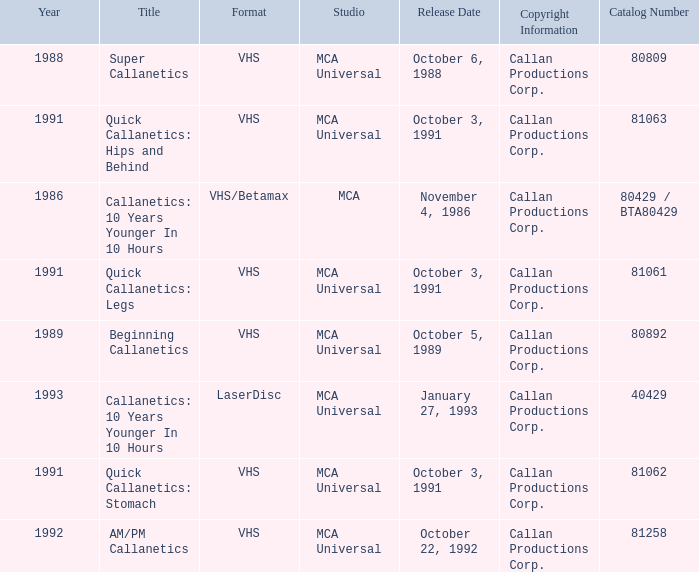Name the format for super callanetics VHS. 